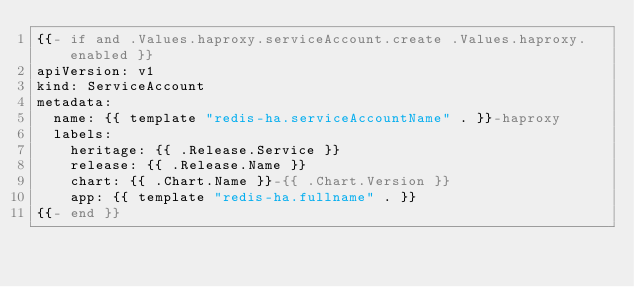<code> <loc_0><loc_0><loc_500><loc_500><_YAML_>{{- if and .Values.haproxy.serviceAccount.create .Values.haproxy.enabled }}
apiVersion: v1
kind: ServiceAccount
metadata:
  name: {{ template "redis-ha.serviceAccountName" . }}-haproxy
  labels:
    heritage: {{ .Release.Service }}
    release: {{ .Release.Name }}
    chart: {{ .Chart.Name }}-{{ .Chart.Version }}
    app: {{ template "redis-ha.fullname" . }}
{{- end }}
</code> 